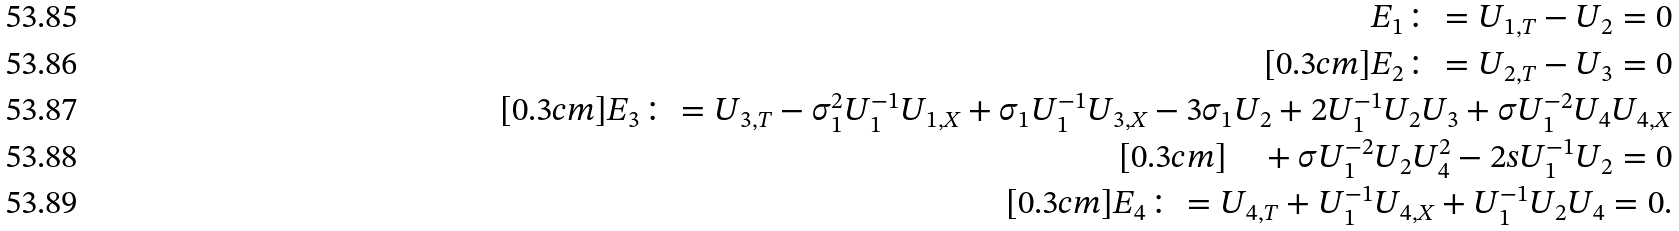<formula> <loc_0><loc_0><loc_500><loc_500>E _ { 1 } \colon = U _ { 1 , T } - U _ { 2 } = 0 \\ [ 0 . 3 c m ] E _ { 2 } \colon = U _ { 2 , T } - U _ { 3 } = 0 \\ [ 0 . 3 c m ] E _ { 3 } \colon = U _ { 3 , T } - \sigma _ { 1 } ^ { 2 } U _ { 1 } ^ { - 1 } U _ { 1 , X } + \sigma _ { 1 } U _ { 1 } ^ { - 1 } U _ { 3 , X } - 3 \sigma _ { 1 } U _ { 2 } + 2 U _ { 1 } ^ { - 1 } U _ { 2 } U _ { 3 } + \sigma U _ { 1 } ^ { - 2 } U _ { 4 } U _ { 4 , X } \\ [ 0 . 3 c m ] \quad + \sigma U _ { 1 } ^ { - 2 } U _ { 2 } U _ { 4 } ^ { 2 } - 2 s U _ { 1 } ^ { - 1 } U _ { 2 } = 0 \\ [ 0 . 3 c m ] E _ { 4 } \colon = U _ { 4 , T } + U _ { 1 } ^ { - 1 } U _ { 4 , X } + U _ { 1 } ^ { - 1 } U _ { 2 } U _ { 4 } = 0 .</formula> 